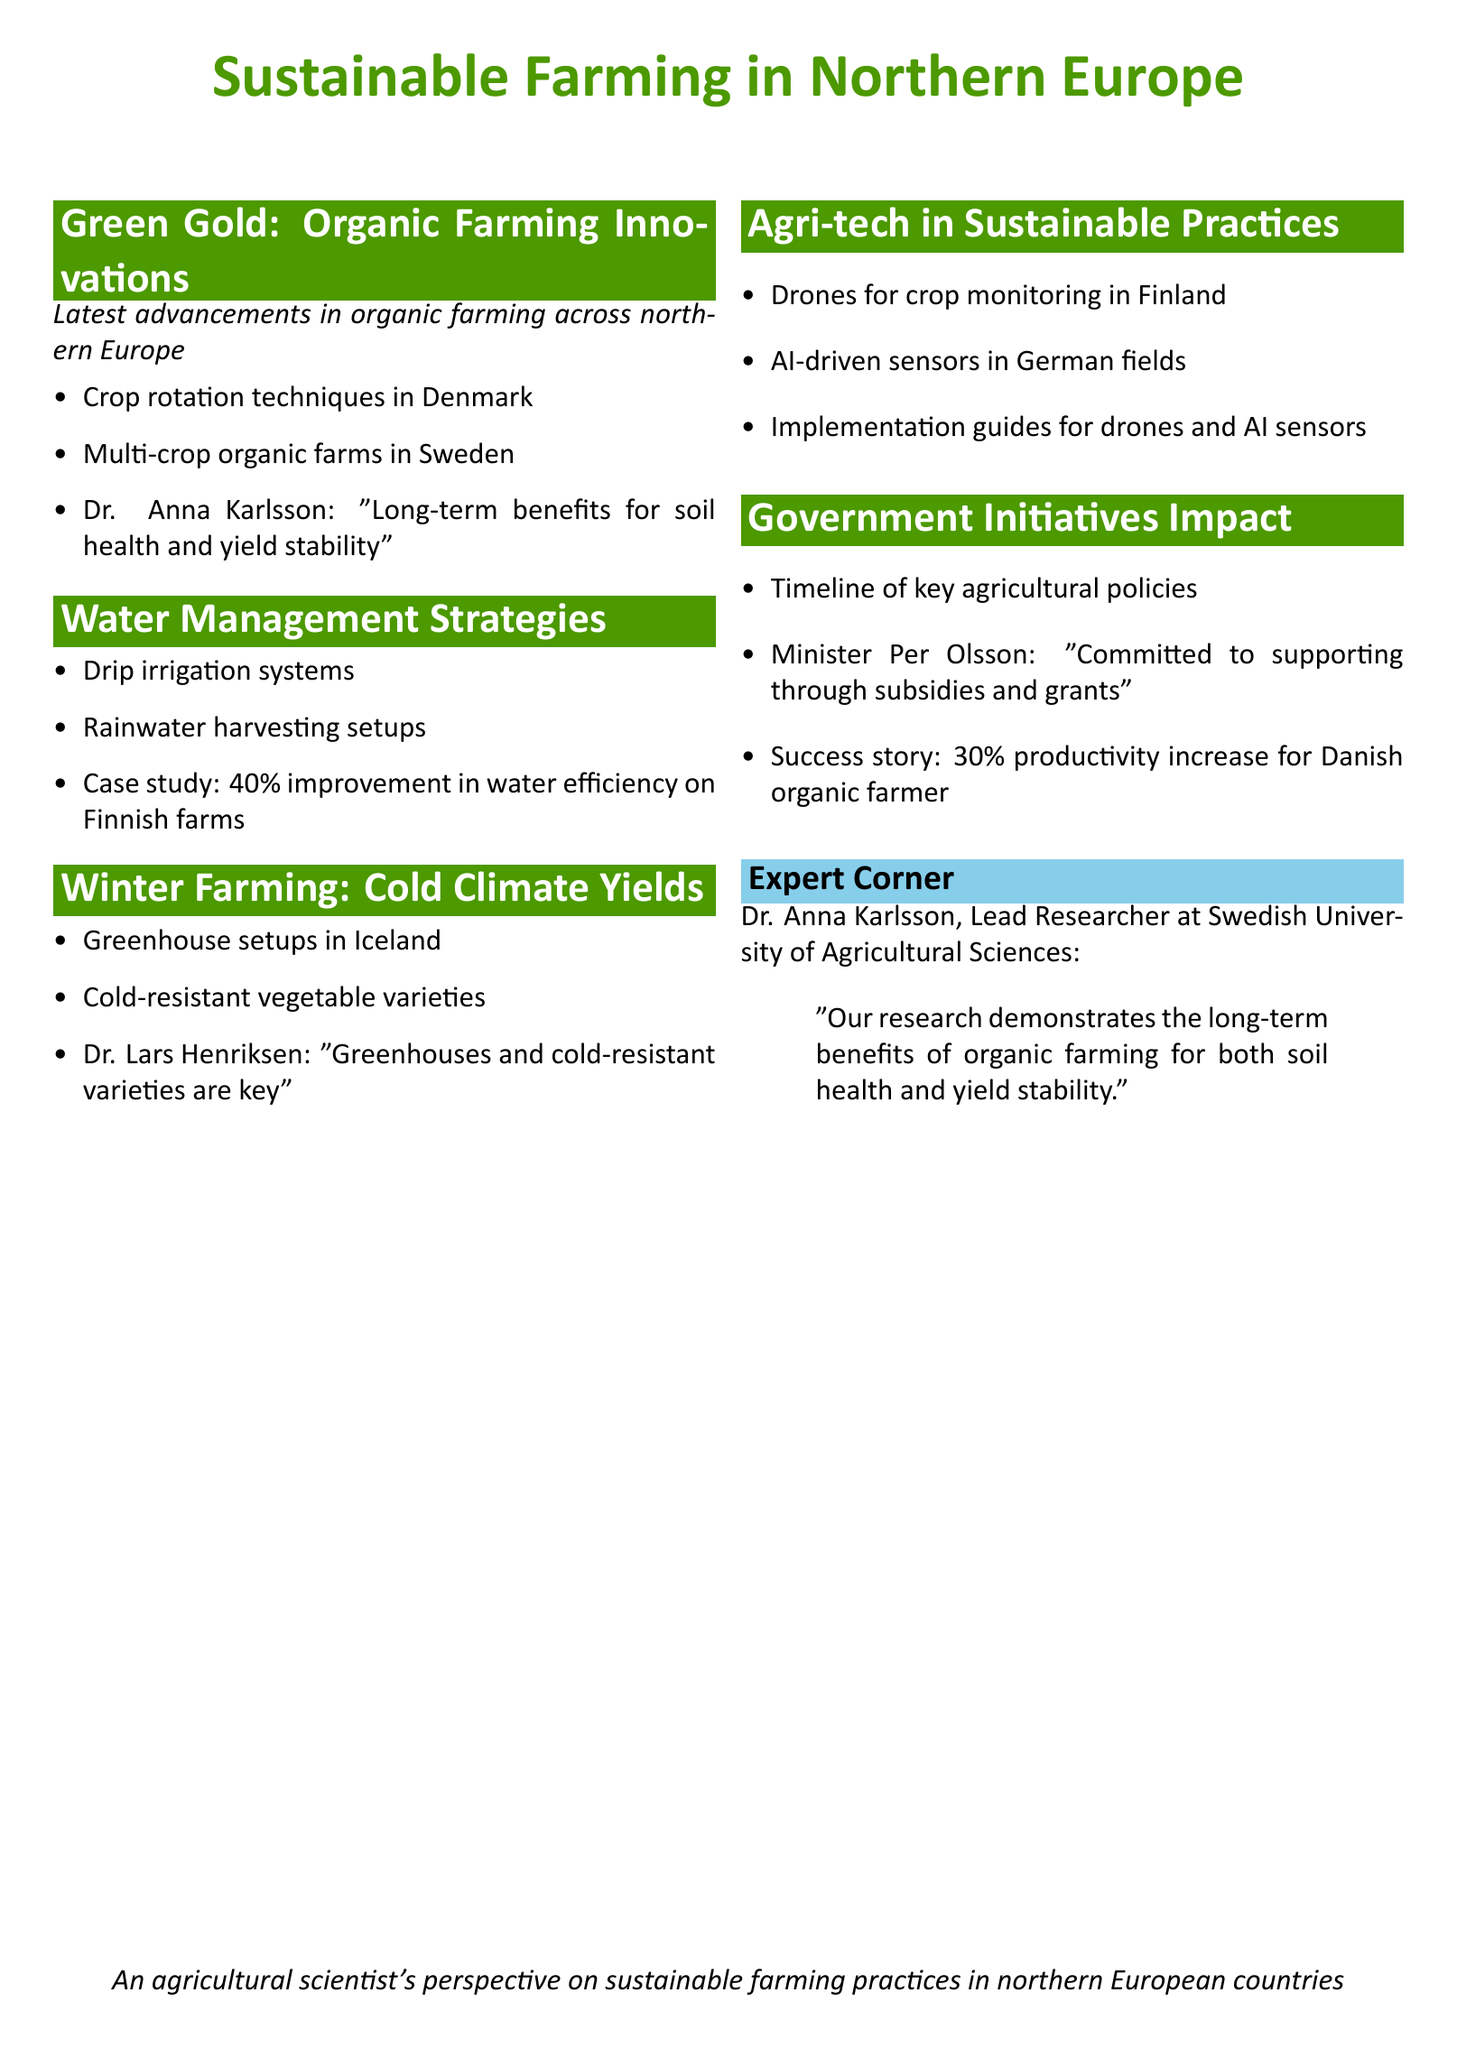What are the advancements in organic farming? The advancements mentioned include crop rotation techniques in Denmark and multi-crop organic farms in Sweden.
Answer: crop rotation techniques, multi-crop organic farms Who is quoted regarding soil health and yield stability? Dr. Anna Karlsson discusses the long-term benefits for soil health and yield stability.
Answer: Dr. Anna Karlsson What percentage improvement in water efficiency is reported for Finnish farms? The document notes a 40% improvement in water efficiency on Finnish farms.
Answer: 40% Which country is highlighted for greenhouse setups? The document mentions Iceland for its greenhouse setups.
Answer: Iceland What is emphasized as key for winter farming according to Dr. Lars Henriksen? Dr. Lars Henriksen emphasizes that greenhouses and cold-resistant varieties are key for winter farming.
Answer: greenhouses, cold-resistant varieties What technology is used for crop monitoring in Finland? The document states that drones are used for crop monitoring in Finland.
Answer: drones What is the productivity increase percentage for the Danish organic farmer? The document reports a 30% productivity increase for a Danish organic farmer.
Answer: 30% Who committed to supporting through subsidies and grants? Minister Per Olsson is quoted regarding the commitment to supporting through subsidies and grants.
Answer: Minister Per Olsson What type of irrigation system is mentioned in the document? The document mentions drip irrigation systems as part of water management strategies.
Answer: drip irrigation systems 